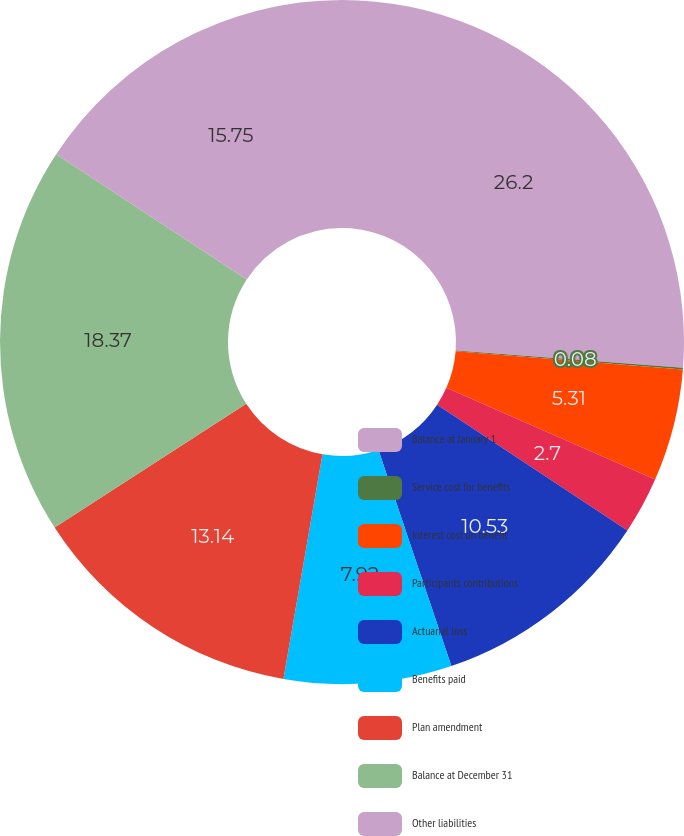Convert chart. <chart><loc_0><loc_0><loc_500><loc_500><pie_chart><fcel>Balance at January 1<fcel>Service cost for benefits<fcel>Interest cost on benefit<fcel>Participants contributions<fcel>Actuarial loss<fcel>Benefits paid<fcel>Plan amendment<fcel>Balance at December 31<fcel>Other liabilities<nl><fcel>26.2%<fcel>0.08%<fcel>5.31%<fcel>2.7%<fcel>10.53%<fcel>7.92%<fcel>13.14%<fcel>18.37%<fcel>15.75%<nl></chart> 